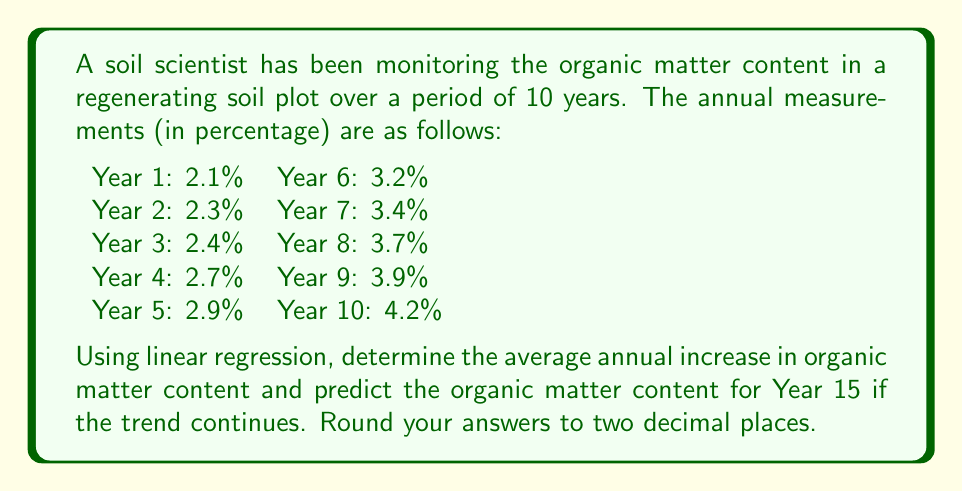Can you answer this question? To solve this problem, we'll use linear regression to analyze the trend in organic matter content over time. Let's follow these steps:

1) First, we need to set up our data. Let $x$ represent the year (1-10) and $y$ represent the organic matter content.

2) We'll use the following formulas for linear regression:

   Slope (m) = $\frac{n\sum xy - \sum x \sum y}{n\sum x^2 - (\sum x)^2}$

   y-intercept (b) = $\frac{\sum y - m\sum x}{n}$

   Where n is the number of data points (10 in this case).

3) Let's calculate the necessary sums:

   $\sum x = 55$
   $\sum y = 30.8$
   $\sum xy = 207.1$
   $\sum x^2 = 385$

4) Now, let's plug these into our slope formula:

   $m = \frac{10(207.1) - 55(30.8)}{10(385) - 55^2}$
   $= \frac{2071 - 1694}{3850 - 3025}$
   $= \frac{377}{825}$
   $= 0.2369$ (rounded to 4 decimal places)

5) Next, let's calculate the y-intercept:

   $b = \frac{30.8 - 0.2369(55)}{10}$
   $= \frac{30.8 - 13.0295}{10}$
   $= 1.77705$

6) So our regression line equation is:

   $y = 0.2369x + 1.77705$

7) The slope, 0.2369, represents the average annual increase in organic matter content.

8) To predict the organic matter content for Year 15, we plug x = 15 into our equation:

   $y = 0.2369(15) + 1.77705$
   $= 3.55335 + 1.77705$
   $= 5.3304$
Answer: The average annual increase in organic matter content is 0.24%.
The predicted organic matter content for Year 15 is 5.33%. 